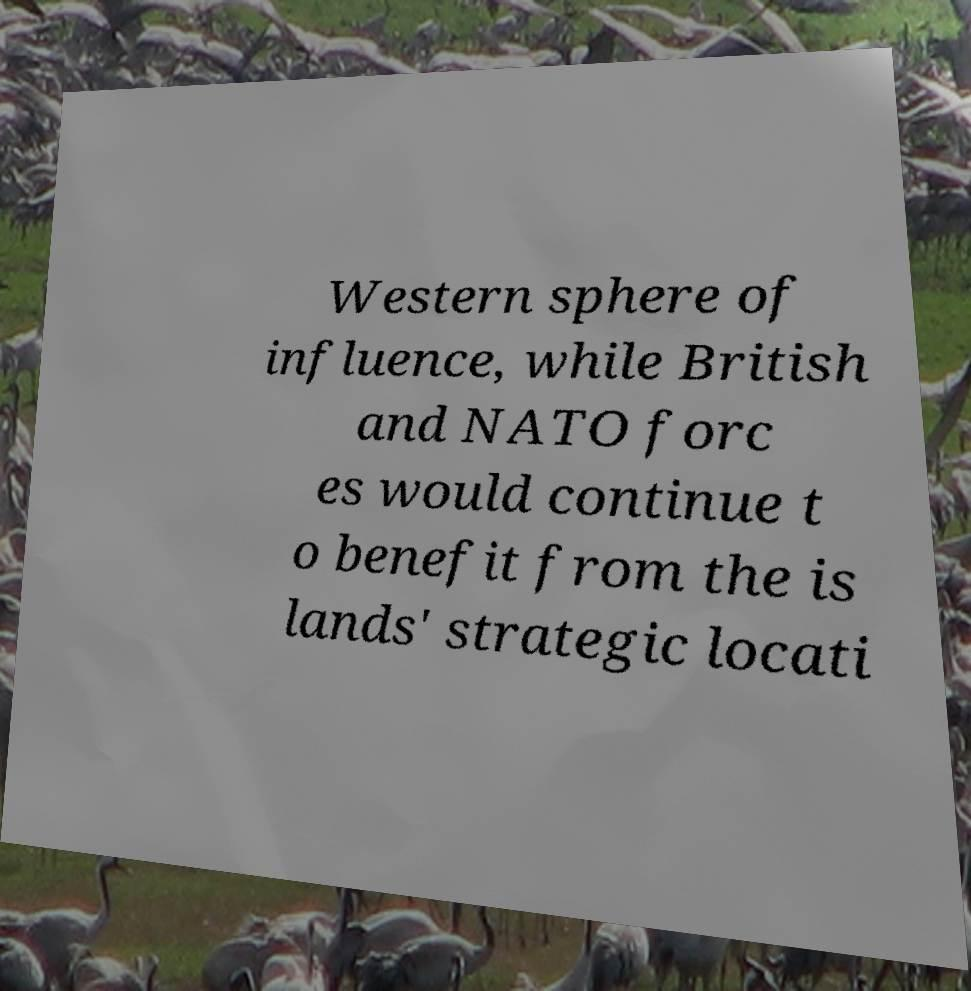I need the written content from this picture converted into text. Can you do that? Western sphere of influence, while British and NATO forc es would continue t o benefit from the is lands' strategic locati 